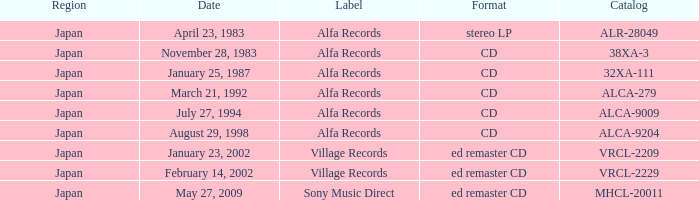Which identifier is associated with february 14, 2002? Village Records. 